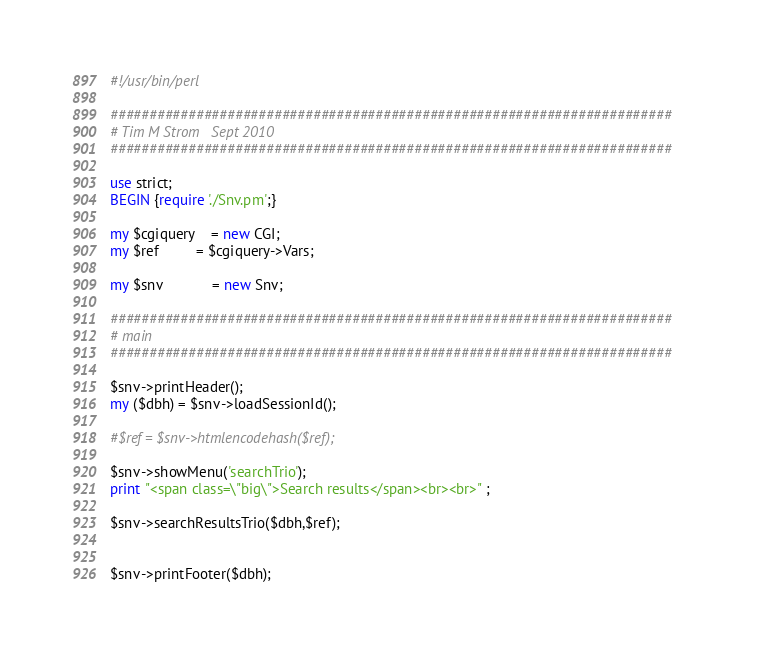<code> <loc_0><loc_0><loc_500><loc_500><_Perl_>#!/usr/bin/perl 

########################################################################
# Tim M Strom   Sept 2010
########################################################################

use strict;
BEGIN {require './Snv.pm';}

my $cgiquery    = new CGI;
my $ref         = $cgiquery->Vars;

my $snv        	= new Snv;

########################################################################
# main
########################################################################

$snv->printHeader();
my ($dbh) = $snv->loadSessionId();

#$ref = $snv->htmlencodehash($ref);

$snv->showMenu('searchTrio');
print "<span class=\"big\">Search results</span><br><br>" ;

$snv->searchResultsTrio($dbh,$ref);


$snv->printFooter($dbh);
</code> 